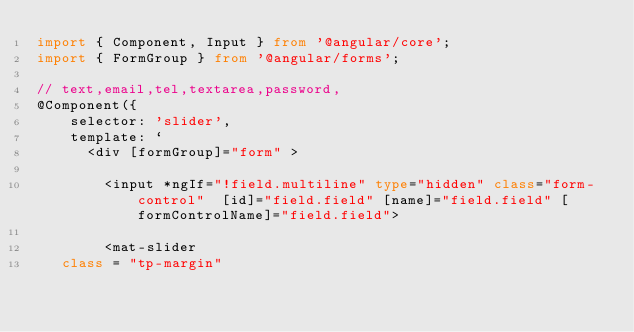<code> <loc_0><loc_0><loc_500><loc_500><_TypeScript_>import { Component, Input } from '@angular/core';
import { FormGroup } from '@angular/forms';

// text,email,tel,textarea,password, 
@Component({
    selector: 'slider',
    template: `
      <div [formGroup]="form" >
    
        <input *ngIf="!field.multiline" type="hidden" class="form-control"  [id]="field.field" [name]="field.field" [formControlName]="field.field">
        
        <mat-slider
   class = "tp-margin"</code> 